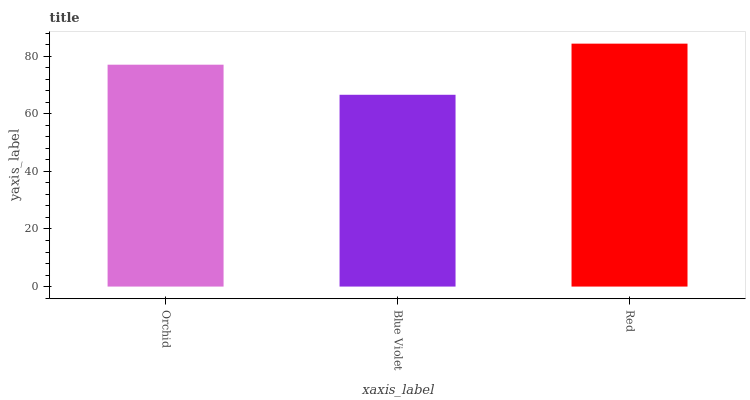Is Blue Violet the minimum?
Answer yes or no. Yes. Is Red the maximum?
Answer yes or no. Yes. Is Red the minimum?
Answer yes or no. No. Is Blue Violet the maximum?
Answer yes or no. No. Is Red greater than Blue Violet?
Answer yes or no. Yes. Is Blue Violet less than Red?
Answer yes or no. Yes. Is Blue Violet greater than Red?
Answer yes or no. No. Is Red less than Blue Violet?
Answer yes or no. No. Is Orchid the high median?
Answer yes or no. Yes. Is Orchid the low median?
Answer yes or no. Yes. Is Red the high median?
Answer yes or no. No. Is Red the low median?
Answer yes or no. No. 